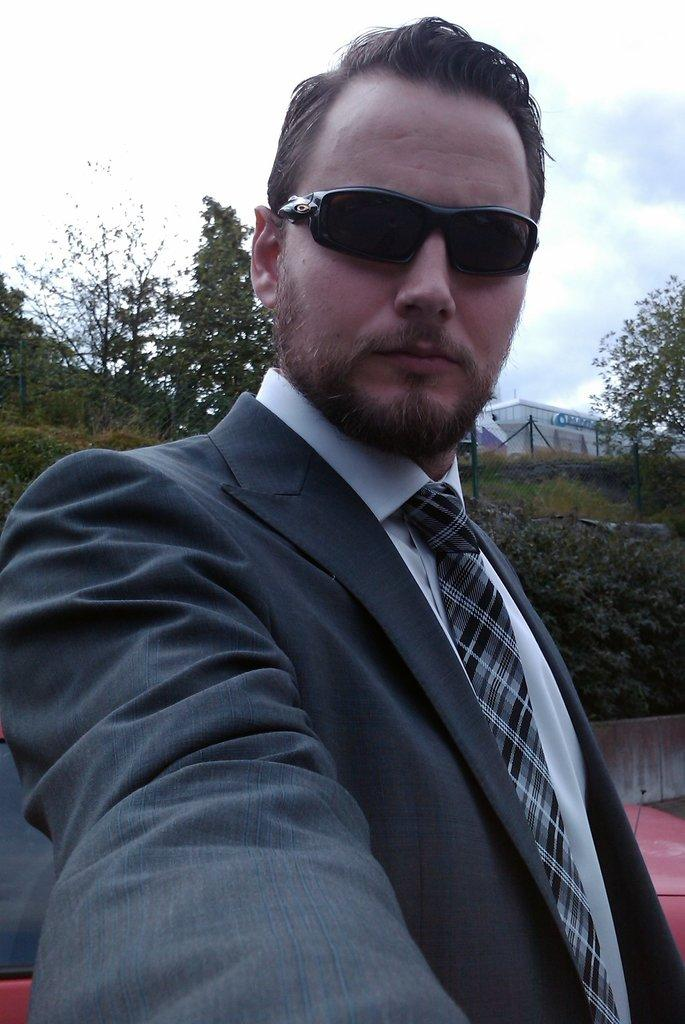Who is in the picture? There is a man in the picture. What is the man wearing? The man is wearing a black coat and a white shirt. What accessory is the man wearing? The man is wearing black sunglasses. What is the man doing in the picture? The man is taking a selfie. What can be seen in the background of the picture? There are trees and a white-colored house visible in the background. What type of noise does the worm make in the picture? There is no worm present in the picture, so it is not possible to determine the noise it might make. 